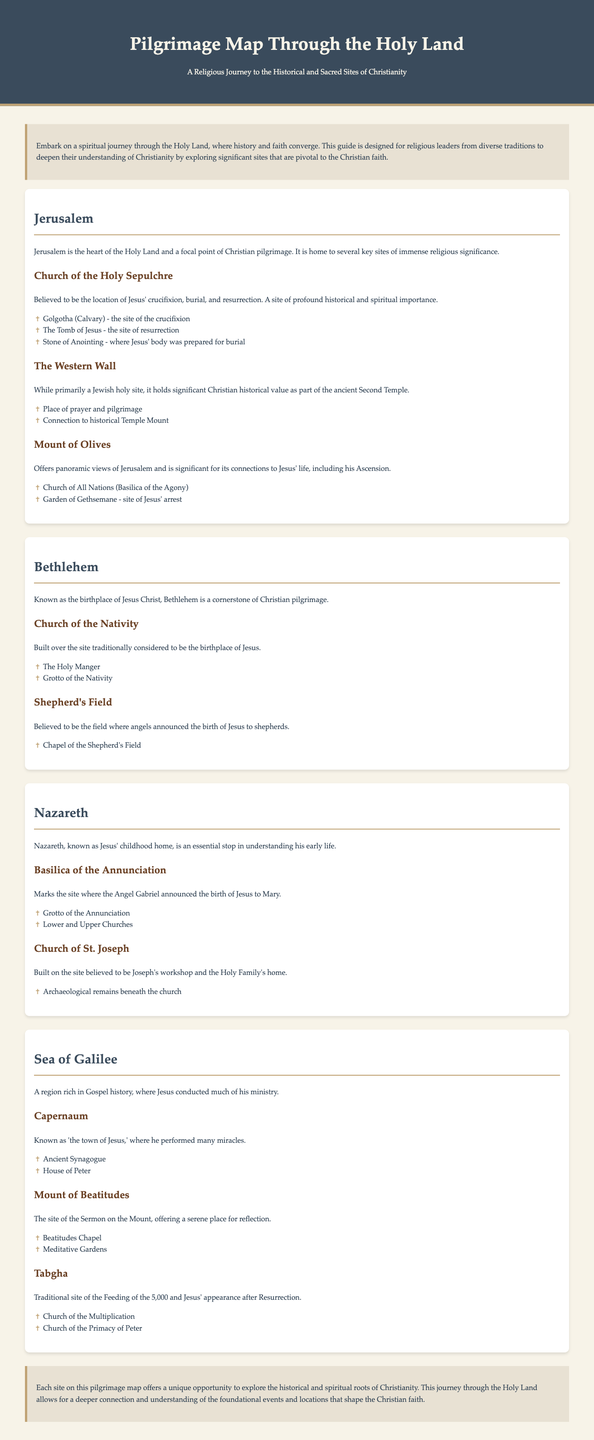What is the title of the document? The title of the document is presented in the header section, which is "Pilgrimage Map Through the Holy Land."
Answer: Pilgrimage Map Through the Holy Land How many locations are highlighted in the document? The document outlines four main locations that are significant in the Holy Land.
Answer: Four What is the significance of the Church of the Holy Sepulchre? This site is detailed as the location of Jesus' crucifixion, burial, and resurrection, emphasizing its importance to Christianity.
Answer: Crucifixion, burial, resurrection What does the Mount of Beatitudes represent? The document identifies it as the site of the Sermon on the Mount, which is a key event in the Gospels.
Answer: Sermon on the Mount Which city is known as the birthplace of Jesus? The document explicitly states that Bethlehem is recognized for being the birthplace of Jesus Christ.
Answer: Bethlehem What is the name of the chapel located in Shepherd's Field? The document mentions that there is a chapel associated with the Shepherd's Field, which is significant for announcing Jesus' birth.
Answer: Chapel of the Shepherd's Field What type of document is this? The content structure is indicative of a guided map or travel guide that focuses on religious and historical sites.
Answer: Guided pilgrimage map Where is the Grotto of the Annunciation located? The document specifies that it is located within the Basilica of the Annunciation in Nazareth.
Answer: Basilica of the Annunciation What is the connection of the Western Wall to Christianity? The document notes that although primarily a Jewish site, it has significant historical value linked to the ancient Second Temple for Christians.
Answer: Ancient Second Temple 